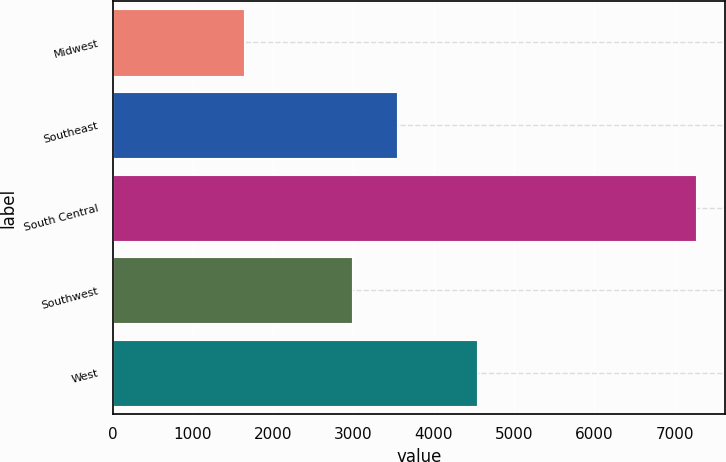<chart> <loc_0><loc_0><loc_500><loc_500><bar_chart><fcel>Midwest<fcel>Southeast<fcel>South Central<fcel>Southwest<fcel>West<nl><fcel>1633<fcel>3545.3<fcel>7266<fcel>2982<fcel>4533<nl></chart> 